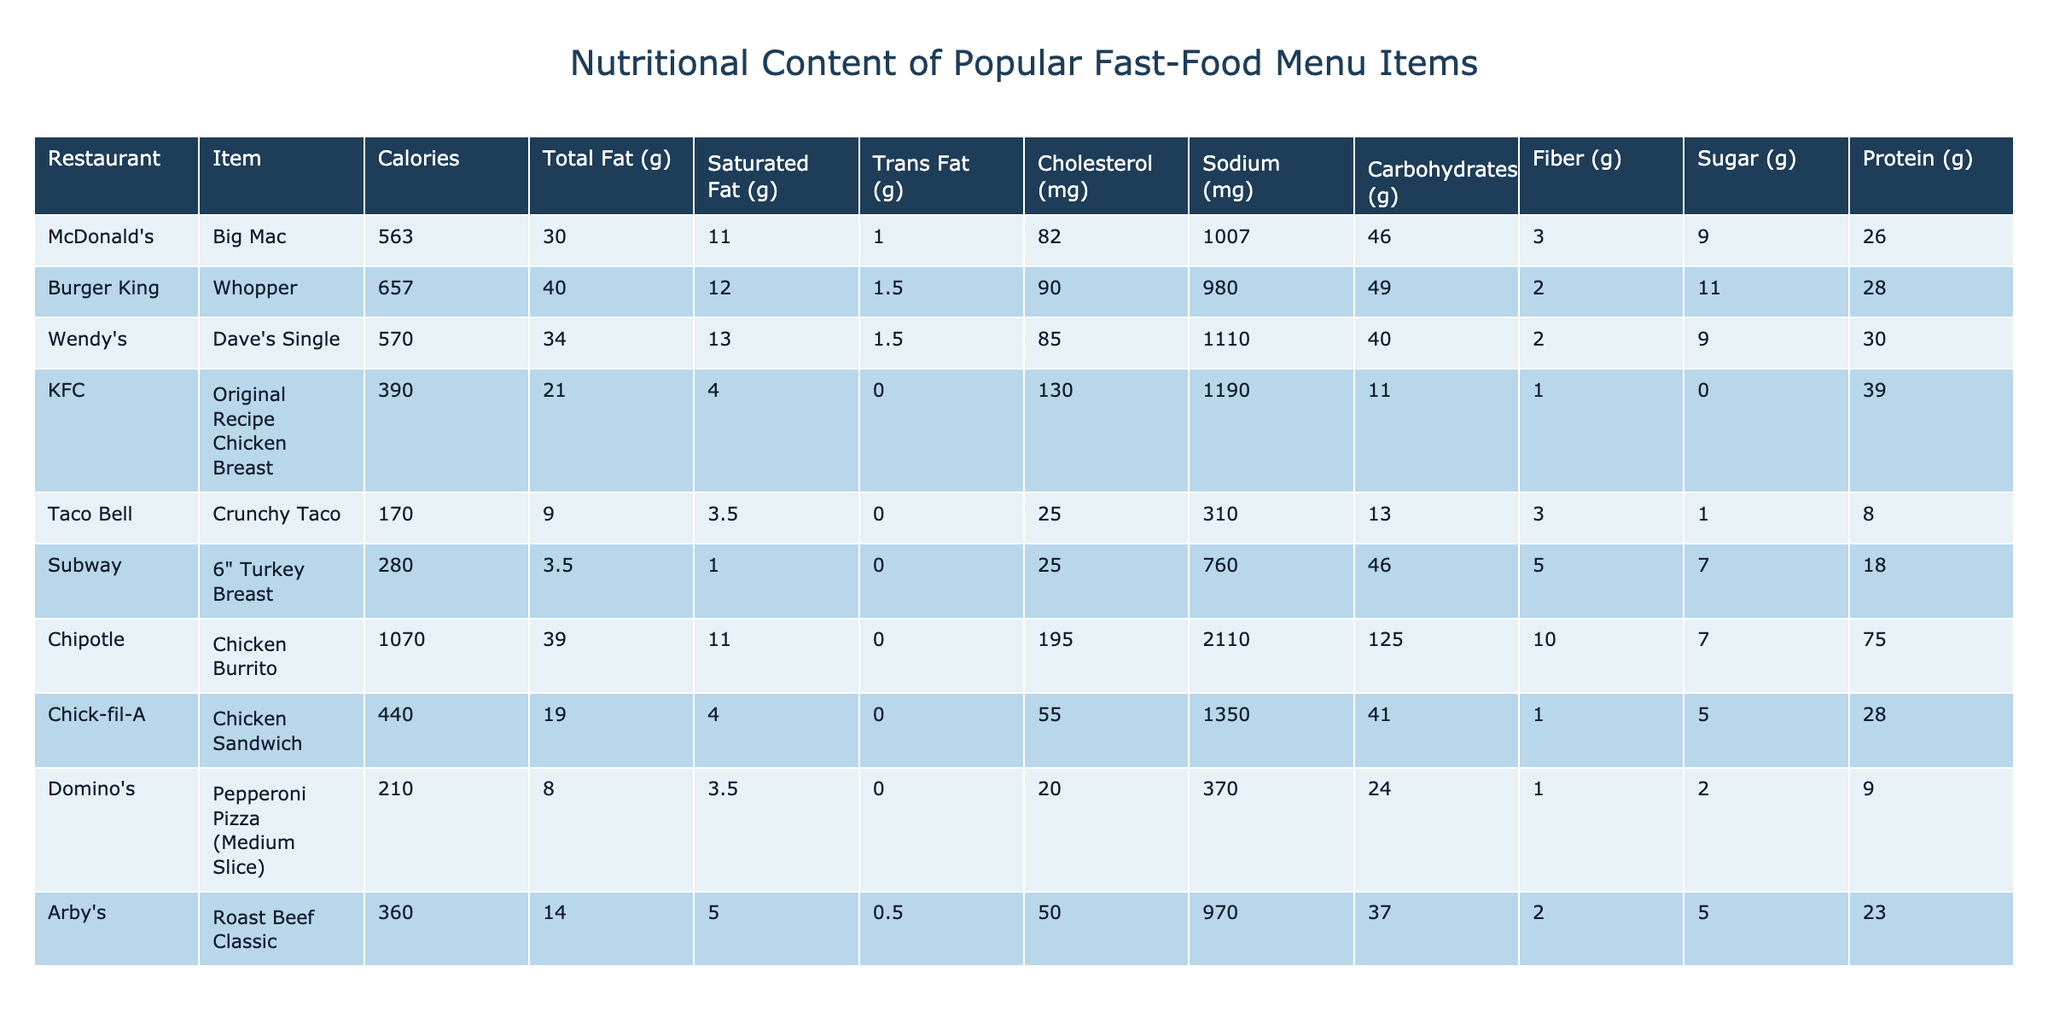What is the highest calorie fast-food item in the table? The table lists the calorie counts for each menu item. The Chicken Burrito from Chipotle has 1070 calories, which is higher than any other item listed.
Answer: 1070 Which menu item has the least amount of sugar? By examining the sugar content of all items in the table, the Crunchy Taco from Taco Bell has the least at 1 gram of sugar.
Answer: 1 What is the total fat content of the Whopper from Burger King? The table directly lists the total fat content for the Whopper, which is 40 grams.
Answer: 40 grams How much protein does Wendy's Dave's Single have compared to Taco Bell's Crunchy Taco? Wendy's Dave's Single has 30 grams of protein, while Taco Bell's Crunchy Taco has only 8 grams. Therefore, Dave's Single has more protein than the Crunchy Taco by 22 grams (30 - 8 = 22).
Answer: 22 grams What is the average sodium content of KFC's Original Recipe Chicken Breast and Chick-fil-A's Chicken Sandwich? The sodium content for the Original Recipe Chicken Breast is 1190 mg, and for the Chicken Sandwich, it's 1350 mg. Adding them gives 1190 + 1350 = 2540 mg. To find the average, divide by 2, so 2540 / 2 = 1270 mg.
Answer: 1270 mg Is the total fat content of a Big Mac greater than that of the Subway Turkey Breast? The total fat for the Big Mac is 30 grams and for the Subway Turkey Breast is 3.5 grams. Since 30 grams is greater than 3.5 grams, the statement is true.
Answer: Yes How many grams of carbohydrates does the Chipotle Chicken Burrito have compared to the Wendy's Dave's Single? The Chicken Burrito has 125 grams of carbohydrates, while Dave's Single has 40 grams. The difference is 125 - 40 = 85 grams, meaning the Burrito has 85 grams more carbohydrates.
Answer: 85 grams Which item has the most saturated fat, and how many grams is it? The table shows that the Chipotle Chicken Burrito has the most saturated fat at 11 grams.
Answer: 11 grams What is the total cholesterol content of the Burger King Whopper and Chick-fil-A Chicken Sandwich? The cholesterol for the Whopper is 90 mg and for the Chicken Sandwich is 55 mg. Adding these gives 90 + 55 = 145 mg of total cholesterol.
Answer: 145 mg How does the sodium content of Subway's Turkey Breast compare to that of KFC's Original Recipe Chicken Breast? Subway's Turkey Breast has 760 mg of sodium, while KFC's Original Recipe Chicken Breast has 1190 mg. Since 1190 mg is greater than 760 mg, KFC's sodium content is higher.
Answer: KFC's sodium content is higher 